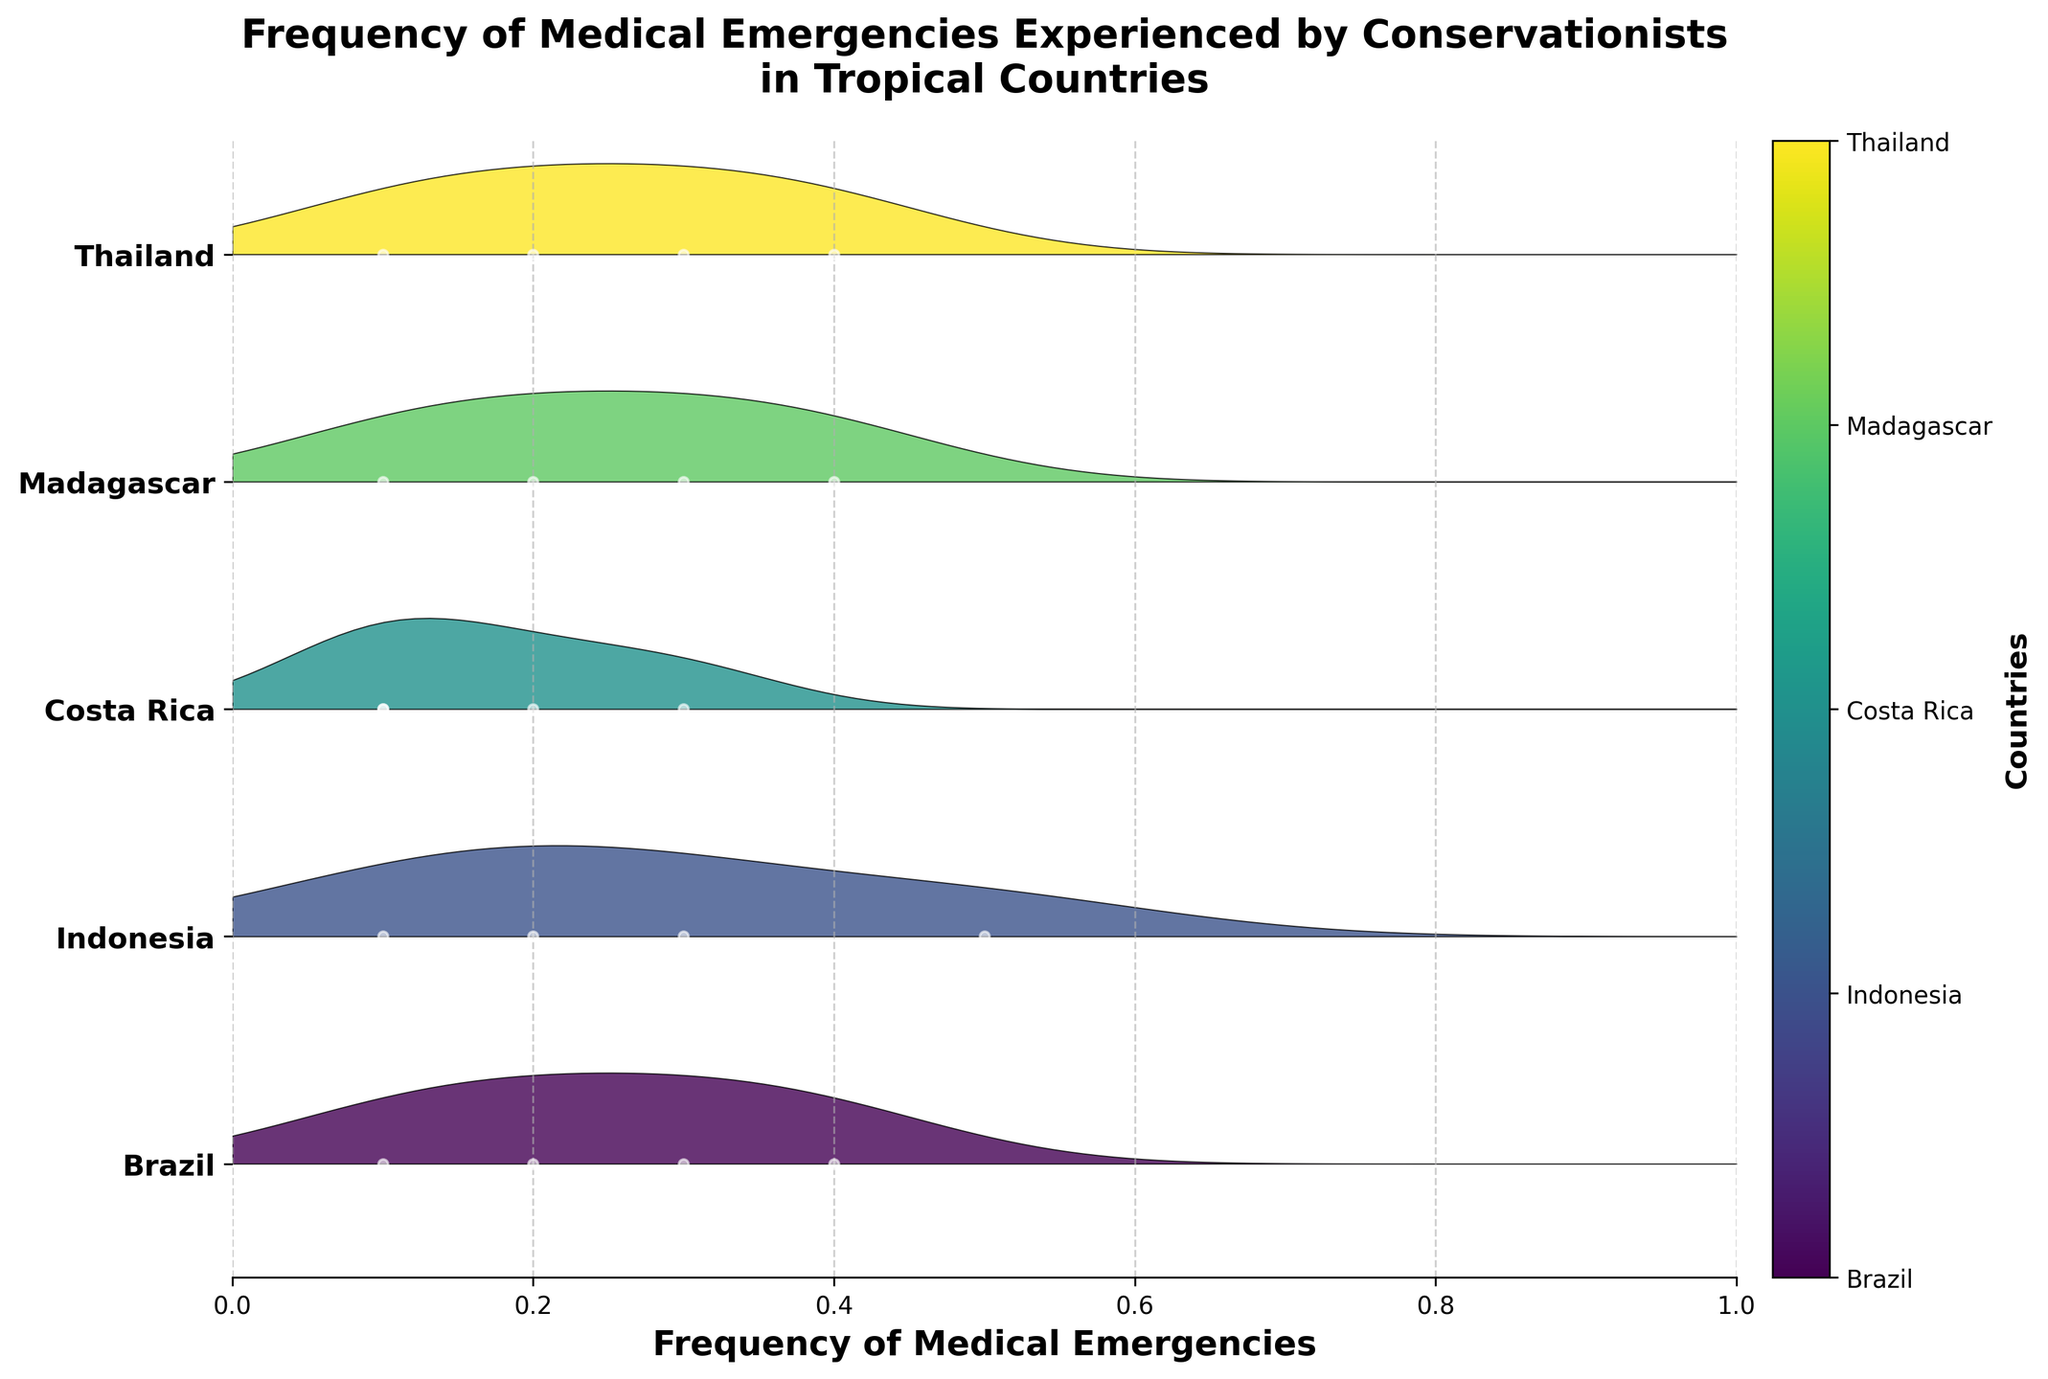What is the range of frequencies shown on the x-axis? The x-axis is labeled 'Frequency of Medical Emergencies' and spans from 0 to 1, as indicated by the limits.
Answer: 0 to 1 Which country has the highest occurrence of 'Malaria'? By examining the peaks and the density regions, Madagascar has the highest occurrence of 'Malaria' with a frequency of 0.4.
Answer: Madagascar How many countries are represented in the plot? The y-axis lists unique countries, and counting these entries reveals there are four countries represented in the plot: Brazil, Indonesia, Costa Rica, and Madagascar.
Answer: 4 Which country experiences the highest frequency of 'Insect bites'? Looking at the density and the plots for each country, Brazil’s plot shows a high frequency of 'Insect bites' at 0.4.
Answer: Brazil In which country is 'Traveler's diarrhea' most common? The plot associated with Costa Rica shows a peaking frequency for 'Traveler's diarrhea', indicating it occurs with a frequency of 0.3 in Costa Rica.
Answer: Costa Rica Between Brazil and Thailand, which country shows higher variability in medical emergencies? Brazil shows a wider spread of frequency values and multiple high-density peaks, indicating higher variability in medical emergencies compared to Thailand, which has fewer distinct peaks.
Answer: Brazil What type of medical emergency has a frequency of 0.4 in Indonesia? From the plot, 'Cuts and infections' is the emergency type with a frequency of 0.4 in Indonesia.
Answer: 'Cuts and infections' Which country experiences 'Food poisoning' and with what frequency? Thailand shows the occurrence of 'Food poisoning' at a frequency of 0.3, evident from the plot's markers and density.
Answer: Thailand (0.3) Which country’s plot has the highest peak overall, and what does it signify? The highest peak in the plot is for Indonesia, with 'Cuts and infections' indicating the most frequent individual emergency in the dataset at a frequency of 0.5.
Answer: Indonesia (Cuts and infections, 0.5) Which country has the least variety in types of medical emergencies and what are those types? Costa Rica demonstrates the least variety, showing only four types of emergencies: Allergic reactions, Traveler's diarrhea, Sunburn, and Sprained ankles. This is clear from its plot, which contains fewer peaks and data points.
Answer: Costa Rica 